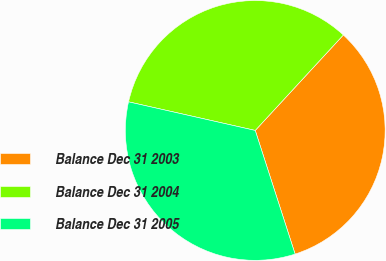Convert chart to OTSL. <chart><loc_0><loc_0><loc_500><loc_500><pie_chart><fcel>Balance Dec 31 2003<fcel>Balance Dec 31 2004<fcel>Balance Dec 31 2005<nl><fcel>33.17%<fcel>33.33%<fcel>33.5%<nl></chart> 